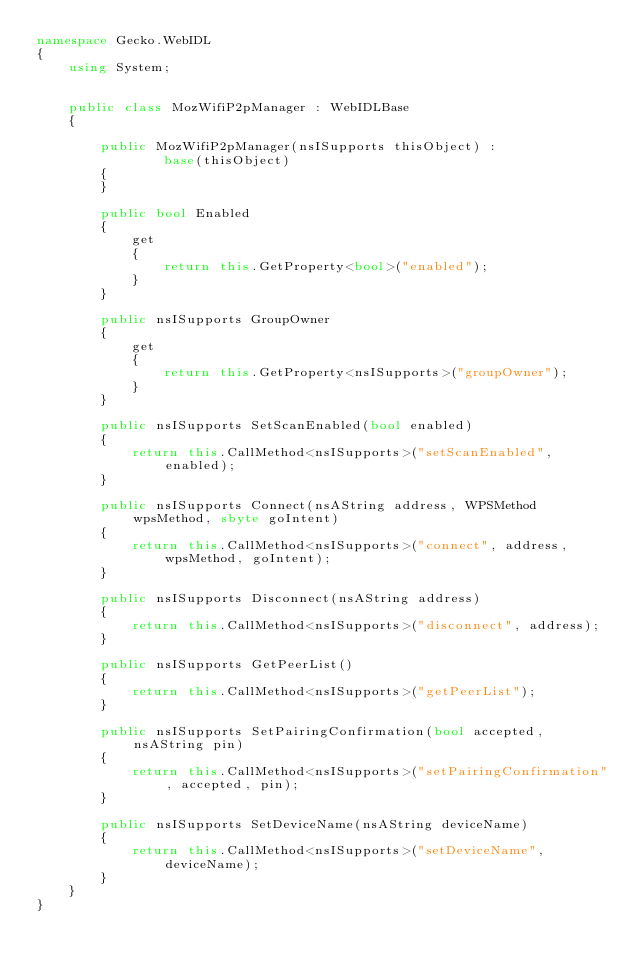<code> <loc_0><loc_0><loc_500><loc_500><_C#_>namespace Gecko.WebIDL
{
    using System;
    
    
    public class MozWifiP2pManager : WebIDLBase
    {
        
        public MozWifiP2pManager(nsISupports thisObject) : 
                base(thisObject)
        {
        }
        
        public bool Enabled
        {
            get
            {
                return this.GetProperty<bool>("enabled");
            }
        }
        
        public nsISupports GroupOwner
        {
            get
            {
                return this.GetProperty<nsISupports>("groupOwner");
            }
        }
        
        public nsISupports SetScanEnabled(bool enabled)
        {
            return this.CallMethod<nsISupports>("setScanEnabled", enabled);
        }
        
        public nsISupports Connect(nsAString address, WPSMethod wpsMethod, sbyte goIntent)
        {
            return this.CallMethod<nsISupports>("connect", address, wpsMethod, goIntent);
        }
        
        public nsISupports Disconnect(nsAString address)
        {
            return this.CallMethod<nsISupports>("disconnect", address);
        }
        
        public nsISupports GetPeerList()
        {
            return this.CallMethod<nsISupports>("getPeerList");
        }
        
        public nsISupports SetPairingConfirmation(bool accepted, nsAString pin)
        {
            return this.CallMethod<nsISupports>("setPairingConfirmation", accepted, pin);
        }
        
        public nsISupports SetDeviceName(nsAString deviceName)
        {
            return this.CallMethod<nsISupports>("setDeviceName", deviceName);
        }
    }
}
</code> 